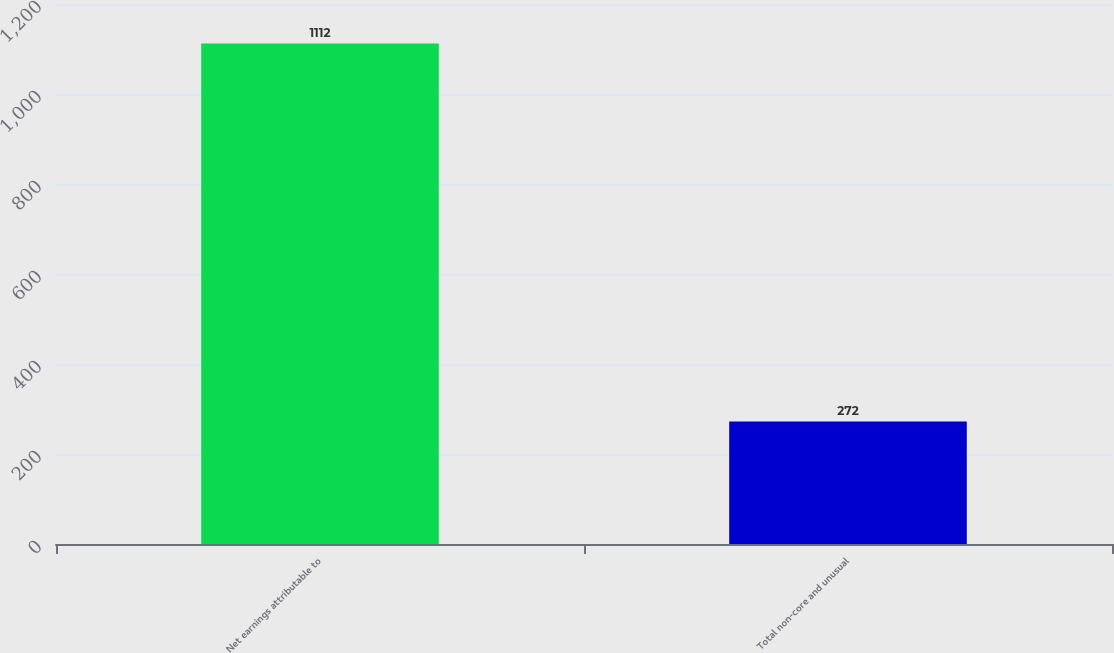<chart> <loc_0><loc_0><loc_500><loc_500><bar_chart><fcel>Net earnings attributable to<fcel>Total non-core and unusual<nl><fcel>1112<fcel>272<nl></chart> 